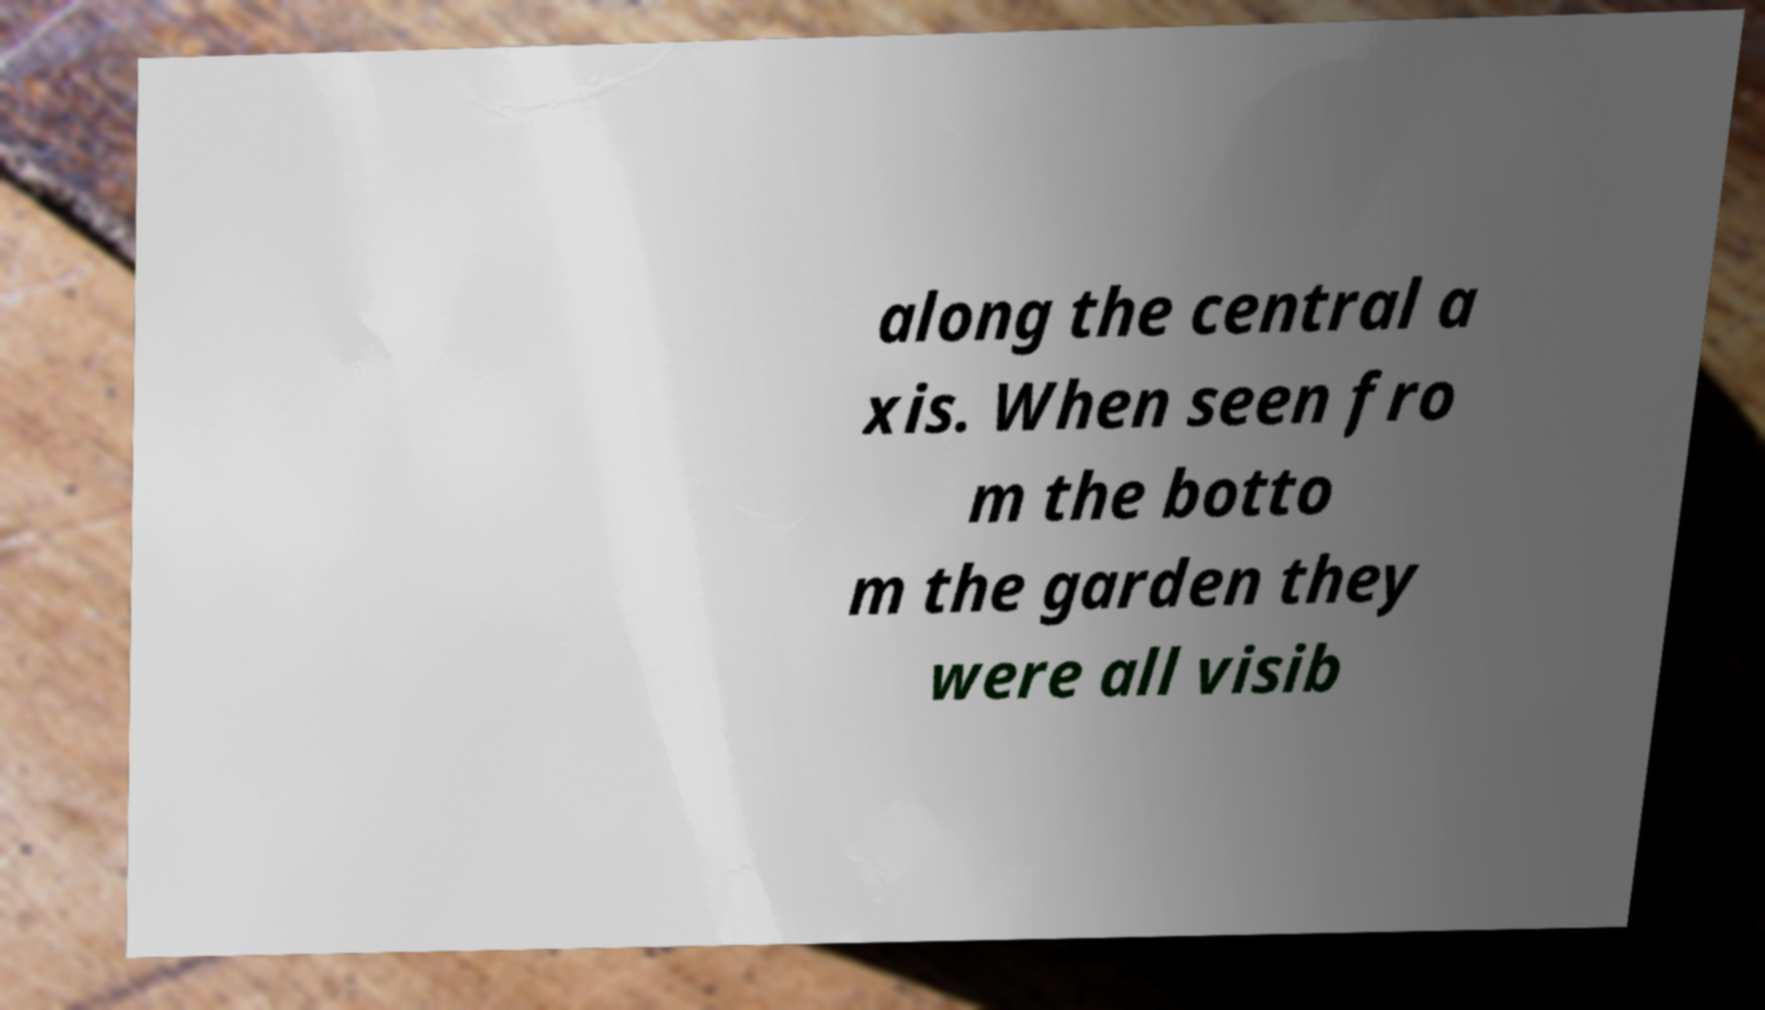Could you assist in decoding the text presented in this image and type it out clearly? along the central a xis. When seen fro m the botto m the garden they were all visib 